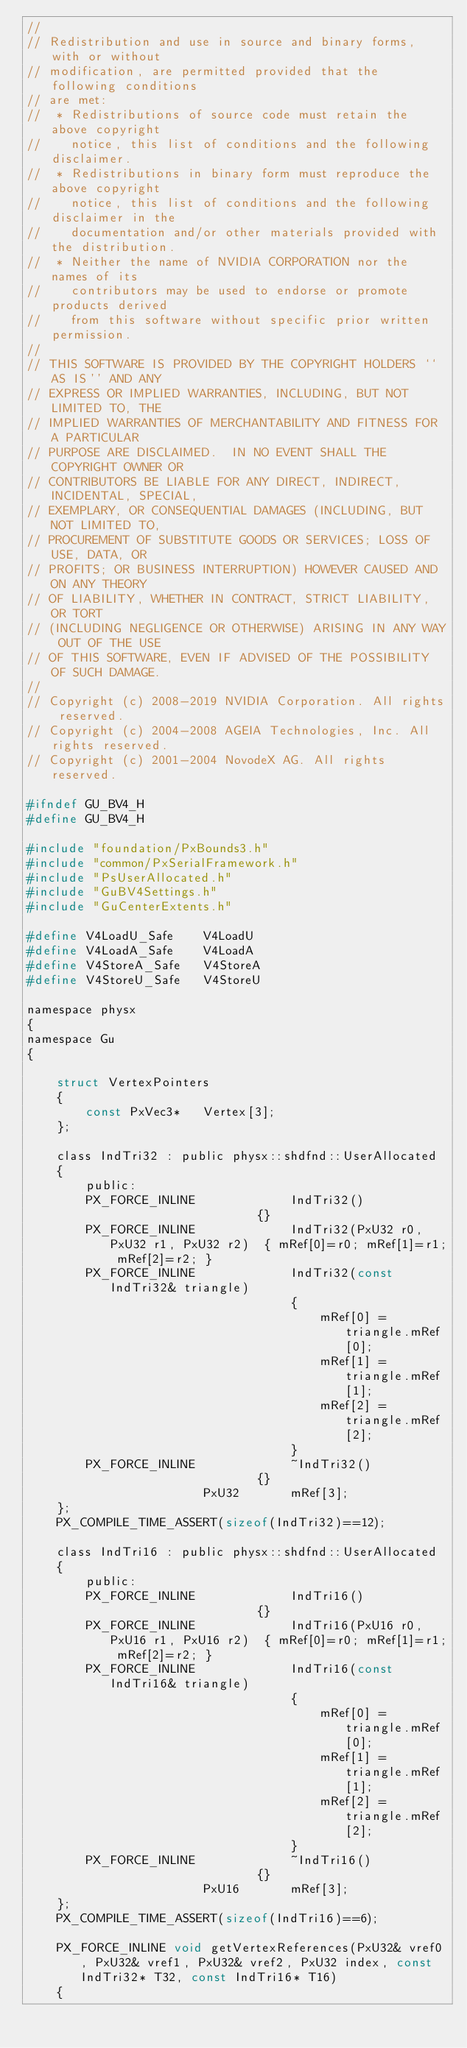Convert code to text. <code><loc_0><loc_0><loc_500><loc_500><_C_>//
// Redistribution and use in source and binary forms, with or without
// modification, are permitted provided that the following conditions
// are met:
//  * Redistributions of source code must retain the above copyright
//    notice, this list of conditions and the following disclaimer.
//  * Redistributions in binary form must reproduce the above copyright
//    notice, this list of conditions and the following disclaimer in the
//    documentation and/or other materials provided with the distribution.
//  * Neither the name of NVIDIA CORPORATION nor the names of its
//    contributors may be used to endorse or promote products derived
//    from this software without specific prior written permission.
//
// THIS SOFTWARE IS PROVIDED BY THE COPYRIGHT HOLDERS ``AS IS'' AND ANY
// EXPRESS OR IMPLIED WARRANTIES, INCLUDING, BUT NOT LIMITED TO, THE
// IMPLIED WARRANTIES OF MERCHANTABILITY AND FITNESS FOR A PARTICULAR
// PURPOSE ARE DISCLAIMED.  IN NO EVENT SHALL THE COPYRIGHT OWNER OR
// CONTRIBUTORS BE LIABLE FOR ANY DIRECT, INDIRECT, INCIDENTAL, SPECIAL,
// EXEMPLARY, OR CONSEQUENTIAL DAMAGES (INCLUDING, BUT NOT LIMITED TO,
// PROCUREMENT OF SUBSTITUTE GOODS OR SERVICES; LOSS OF USE, DATA, OR
// PROFITS; OR BUSINESS INTERRUPTION) HOWEVER CAUSED AND ON ANY THEORY
// OF LIABILITY, WHETHER IN CONTRACT, STRICT LIABILITY, OR TORT
// (INCLUDING NEGLIGENCE OR OTHERWISE) ARISING IN ANY WAY OUT OF THE USE
// OF THIS SOFTWARE, EVEN IF ADVISED OF THE POSSIBILITY OF SUCH DAMAGE.
//
// Copyright (c) 2008-2019 NVIDIA Corporation. All rights reserved.
// Copyright (c) 2004-2008 AGEIA Technologies, Inc. All rights reserved.
// Copyright (c) 2001-2004 NovodeX AG. All rights reserved.  

#ifndef GU_BV4_H
#define GU_BV4_H

#include "foundation/PxBounds3.h"
#include "common/PxSerialFramework.h"
#include "PsUserAllocated.h"
#include "GuBV4Settings.h"
#include "GuCenterExtents.h"

#define V4LoadU_Safe	V4LoadU
#define V4LoadA_Safe	V4LoadA
#define V4StoreA_Safe	V4StoreA
#define V4StoreU_Safe	V4StoreU

namespace physx
{
namespace Gu
{

	struct VertexPointers
	{
		const PxVec3*	Vertex[3];
	};

	class IndTri32 : public physx::shdfnd::UserAllocated
	{
		public:
		PX_FORCE_INLINE				IndTri32()								{}
		PX_FORCE_INLINE				IndTri32(PxU32 r0, PxU32 r1, PxU32 r2)	{ mRef[0]=r0; mRef[1]=r1; mRef[2]=r2; }
		PX_FORCE_INLINE				IndTri32(const IndTri32& triangle)
									{
										mRef[0] = triangle.mRef[0];
										mRef[1] = triangle.mRef[1];
										mRef[2] = triangle.mRef[2];
									}
		PX_FORCE_INLINE				~IndTri32()								{}
						PxU32		mRef[3];
	};
	PX_COMPILE_TIME_ASSERT(sizeof(IndTri32)==12);

	class IndTri16 : public physx::shdfnd::UserAllocated
	{
		public:
		PX_FORCE_INLINE				IndTri16()								{}
		PX_FORCE_INLINE				IndTri16(PxU16 r0, PxU16 r1, PxU16 r2)	{ mRef[0]=r0; mRef[1]=r1; mRef[2]=r2; }
		PX_FORCE_INLINE				IndTri16(const IndTri16& triangle)
									{
										mRef[0] = triangle.mRef[0];
										mRef[1] = triangle.mRef[1];
										mRef[2] = triangle.mRef[2];
									}
		PX_FORCE_INLINE				~IndTri16()								{}
						PxU16		mRef[3];
	};
	PX_COMPILE_TIME_ASSERT(sizeof(IndTri16)==6);

	PX_FORCE_INLINE void getVertexReferences(PxU32& vref0, PxU32& vref1, PxU32& vref2, PxU32 index, const IndTri32* T32, const IndTri16* T16)
	{</code> 